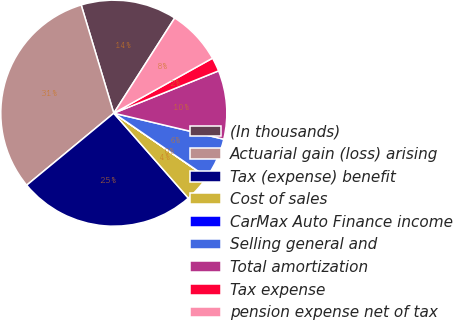Convert chart to OTSL. <chart><loc_0><loc_0><loc_500><loc_500><pie_chart><fcel>(In thousands)<fcel>Actuarial gain (loss) arising<fcel>Tax (expense) benefit<fcel>Cost of sales<fcel>CarMax Auto Finance income<fcel>Selling general and<fcel>Total amortization<fcel>Tax expense<fcel>pension expense net of tax<nl><fcel>13.72%<fcel>31.34%<fcel>25.47%<fcel>3.93%<fcel>0.02%<fcel>5.89%<fcel>9.81%<fcel>1.98%<fcel>7.85%<nl></chart> 